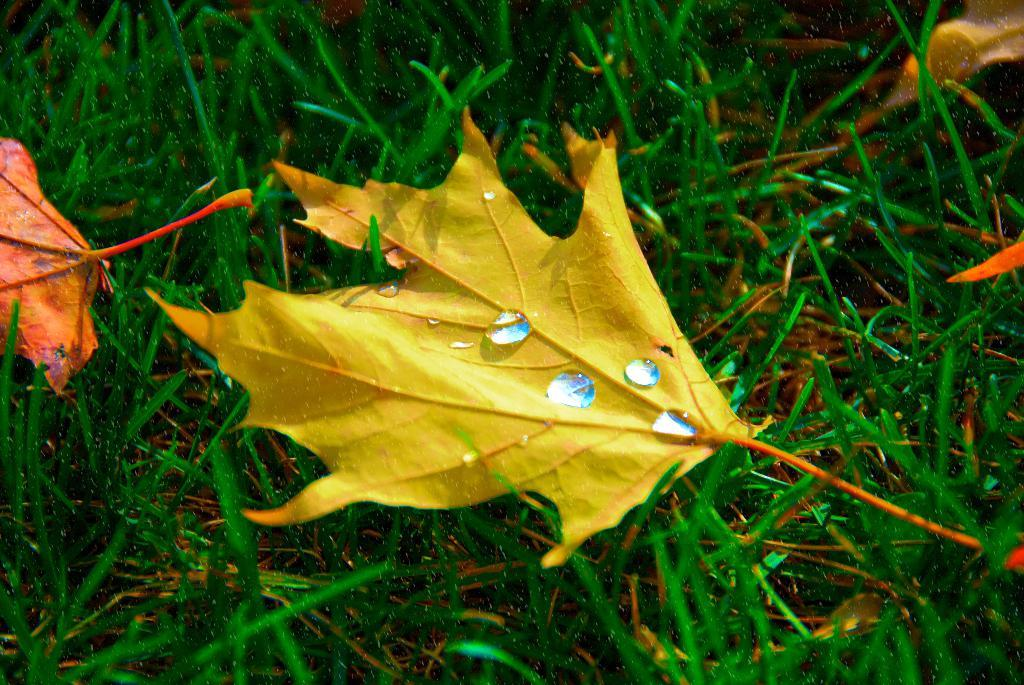What type of vegetation can be seen on the grass in the image? There are leaves on the grass in the image. Can you describe a specific leaf in the image? There is a yellow color leaf in the image. What is present on the yellow color leaf? There are water droplets on the yellow color leaf. Where is the playground located in the image? There is no playground present in the image. What type of frame is visible around the image? The image does not show a frame around it. 